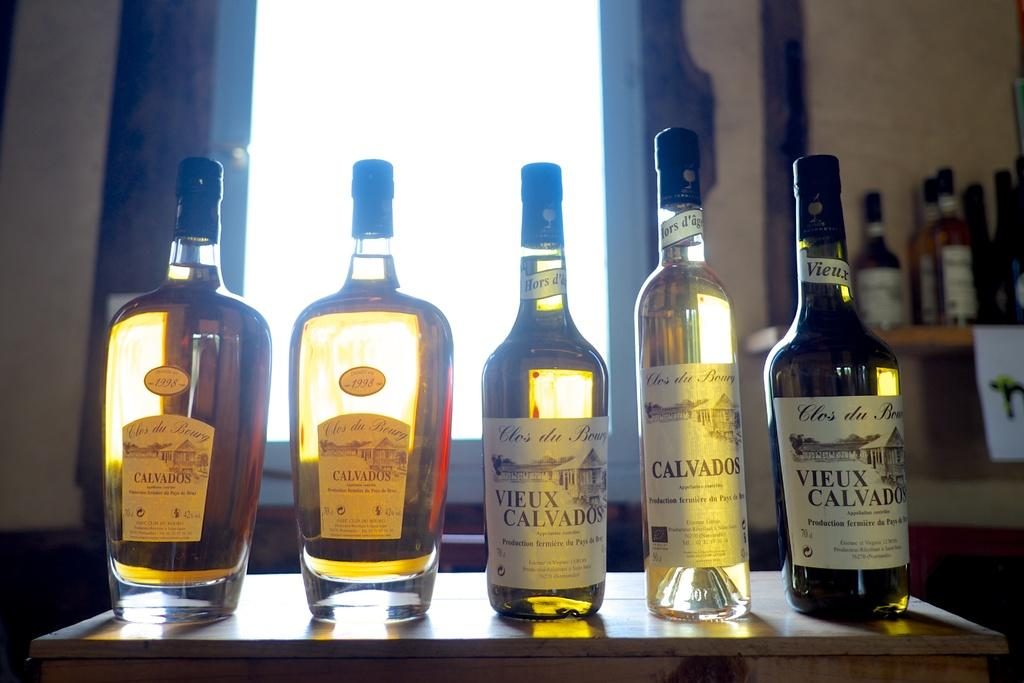<image>
Create a compact narrative representing the image presented. Several bottles are lined up, including one whose label reads "Vieux Calvados" 